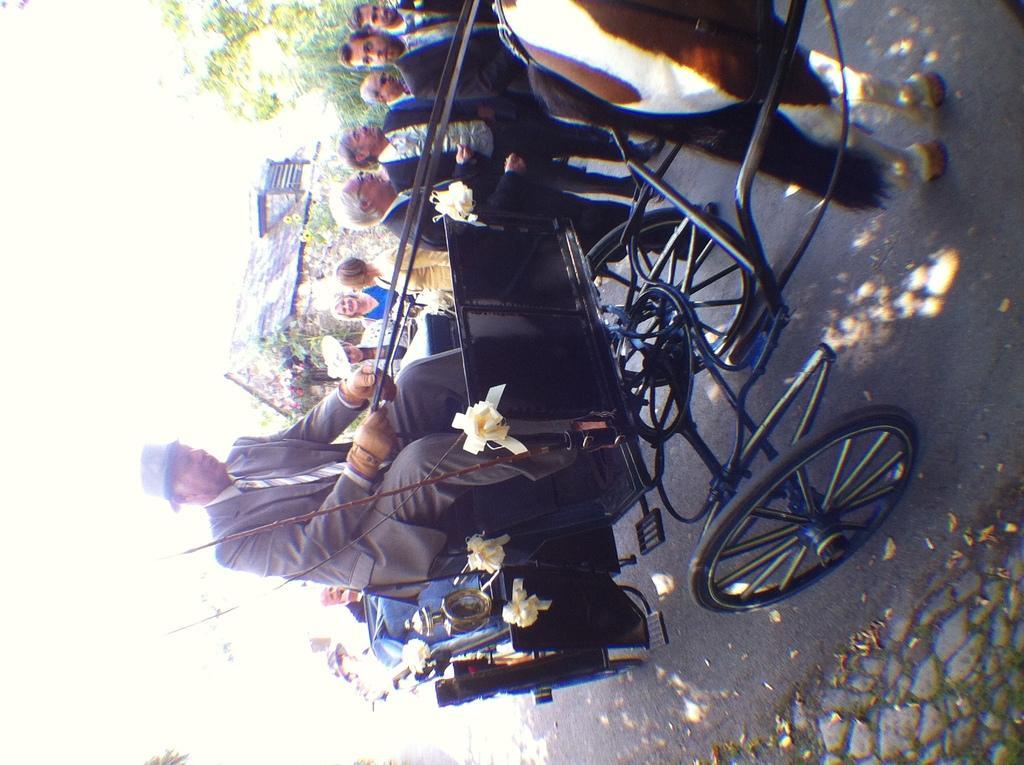Describe this image in one or two sentences. In this image we can see a few people, one of them is riding the horse kart, there are some flowers on it, there are trees, house, and a horse. 